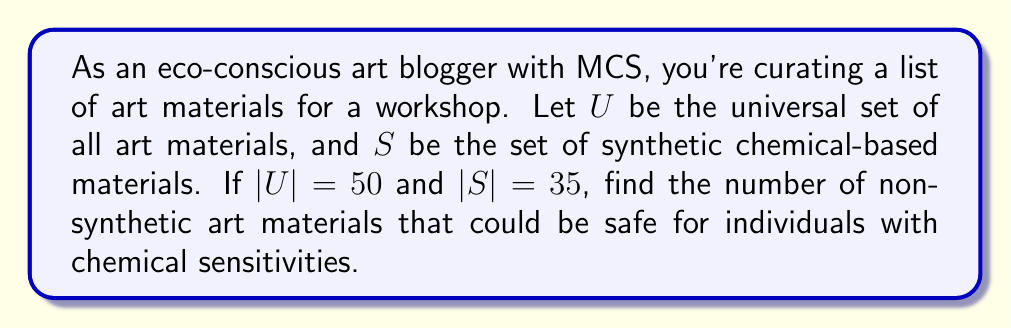Help me with this question. To solve this problem, we need to find the complement of the set $S$ with respect to the universal set $U$. This complement represents the non-synthetic art materials.

Let's denote the complement of $S$ as $S^c$.

1) The complement of a set is defined as all elements in the universal set that are not in the given set.

2) We can calculate the number of elements in the complement using the formula:
   $$|S^c| = |U| - |S|$$

3) We're given:
   $|U| = 50$ (total number of art materials)
   $|S| = 35$ (number of synthetic chemical-based materials)

4) Substituting these values into our formula:
   $$|S^c| = 50 - 35 = 15$$

Therefore, there are 15 non-synthetic art materials in the universal set.
Answer: $|S^c| = 15$ 